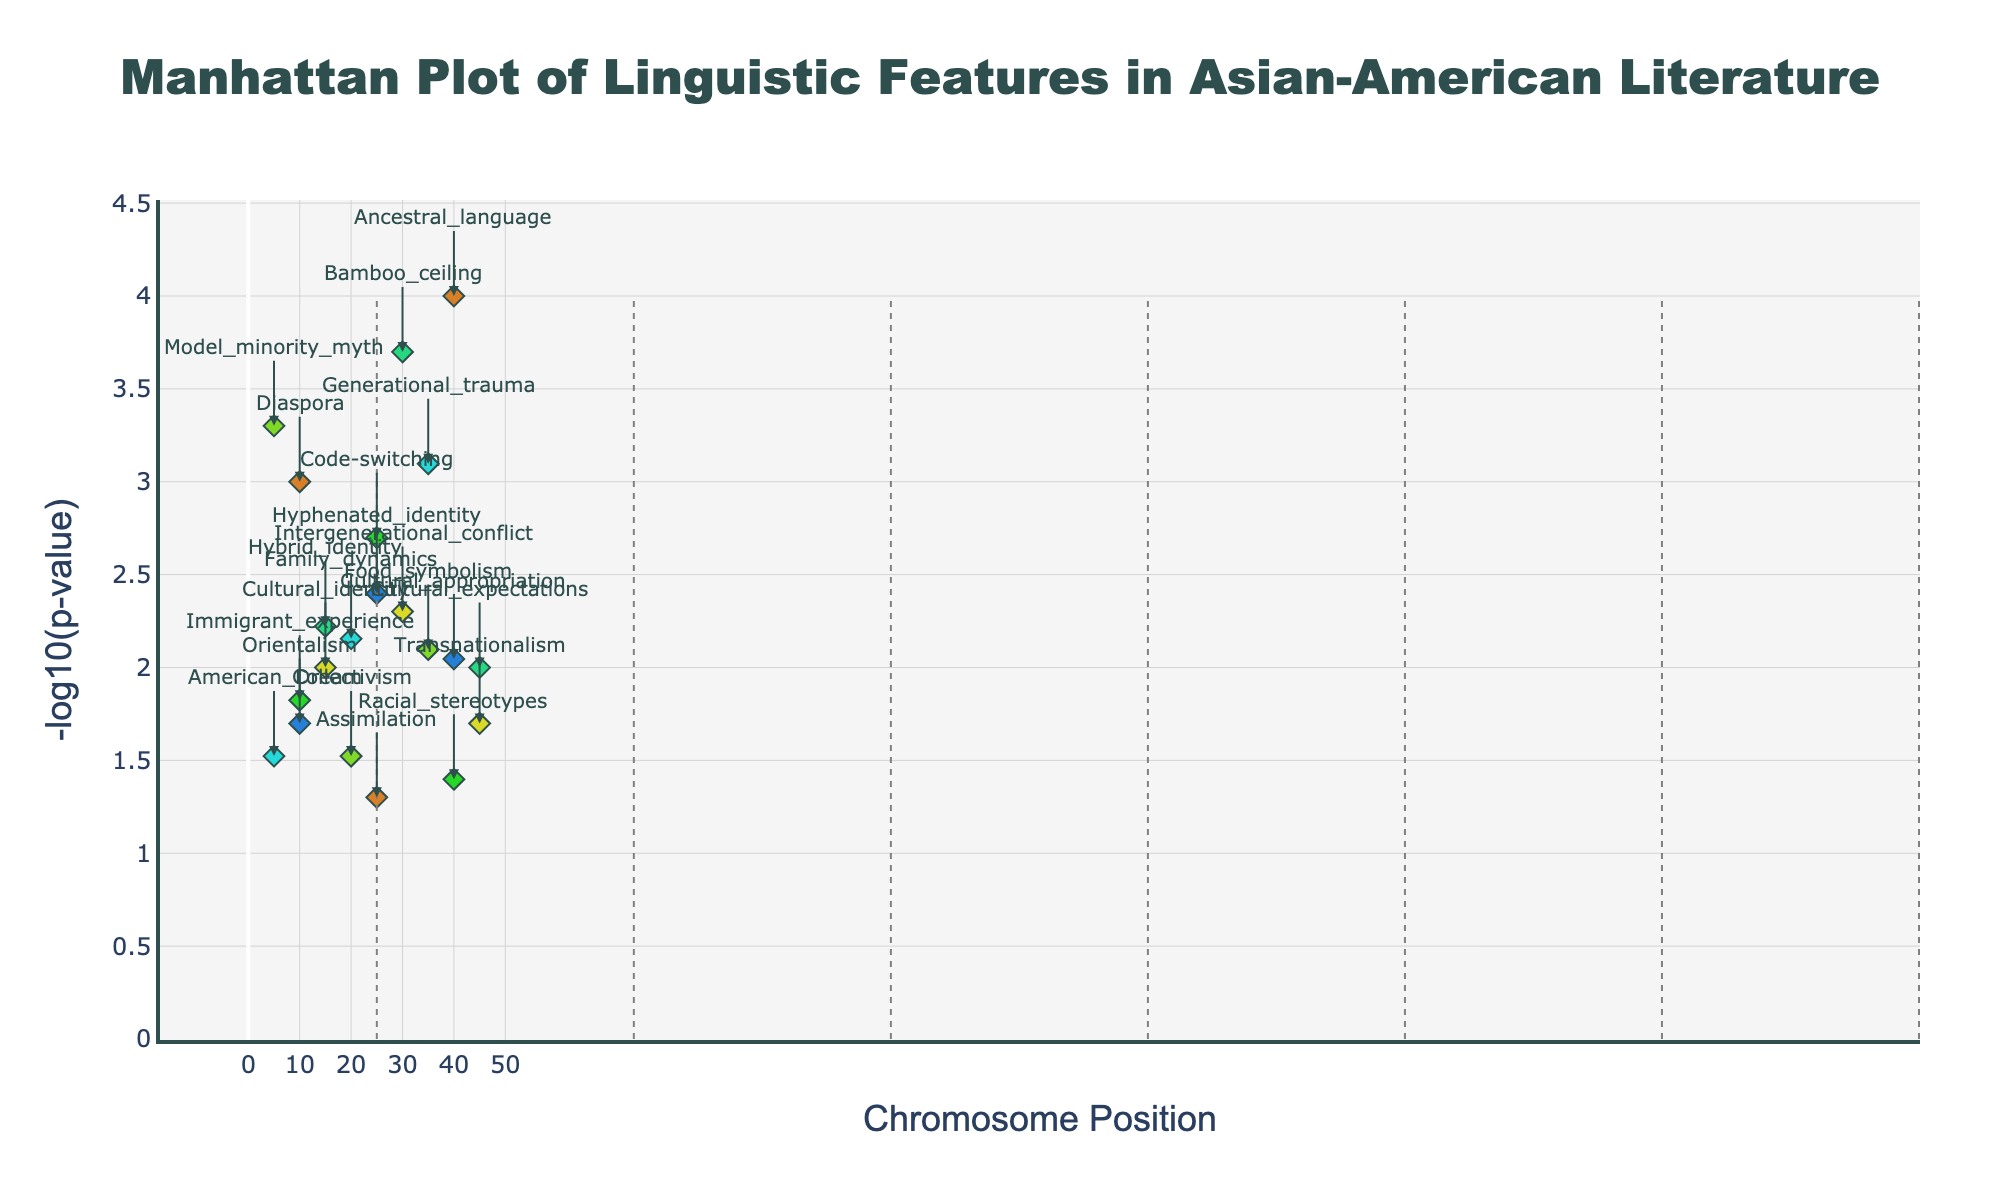What is the title of the plot? The title is displayed at the top of the figure, usually in a larger font size and bold style. The exact text reads, 'Manhattan Plot of Linguistic Features in Asian-American Literature'.
Answer: Manhattan Plot of Linguistic Features in Asian-American Literature What does the y-axis represent? The y-axis title can be found alongside the vertical axis and it explains that the y-axis represents '-log10(p-value)'. This indicates that higher values on the y-axis correspond to more significant linguistic features.
Answer: -log10(p-value) Which chromosome has the feature with the highest score? Look at the y-axis for the highest point. The feature 'Ancestral_language' on chromosome 1 has the highest score. This can be confirmed by checking both the chromosome number and feature name annotated near the highest point on the plot.
Answer: Chromosome 1 How many features are plotted for chromosome 4? Chromosome 4 has three distinct feature scores. Observing the individual points labeled as 'Immigrant_experience', 'Code-switching', and 'Racial_stereotypes' confirms this.
Answer: 3 Which feature on chromosome 5 has the lowest score? Locate chromosome 5 on the x-axis and then identify the point with the lowest y-value (smallest -log10(p-value)). The feature 'Hybrid_identity' is the one with the lowest score on chromosome 5.
Answer: Hybrid_identity What is the average -log10(p-value) of the features on chromosome 2? Find the -log10(p-value) for each feature on chromosome 2: 'Cultural_identity' (2), 'Intergenerational_conflict' (2.3), and 'Transnationalism' (1.7). The average is calculated as (2 + 2.3 + 1.7) / 3 ≈ 2.00.
Answer: 2.00 Which feature has a score of around 3 on chromosome 6? Locate chromosome 6 and find the feature with a score close to 3 on the y-axis. The annotation near that point is 'Generational_trauma', confirming it as the feature with a score of around 3.
Answer: Generational_trauma Compare the highest scoring feature on chromosome 3 to that on chromosome 7. Which has a higher score and by how much? 'Model_minority_myth' is the highest feature on Chromosome 3 (3.3), and 'Hyphenated_identity' is the highest on Chromosome 7 (2.4). The difference is found by subtracting 2.4 from 3.3, giving 0.9.
Answer: Model_minority_myth, by 0.9 What is the median -log10(p-value) for features on chromosome 7? Identify the values on chromosome 7, which are 'Orientalism' (1.7), 'Hyphenated_identity' (2.4), and 'Cultural_appropriation' (2.0). Arrange these as {1.7, 2.0, 2.4} and find the median: 2.0.
Answer: 2.0 